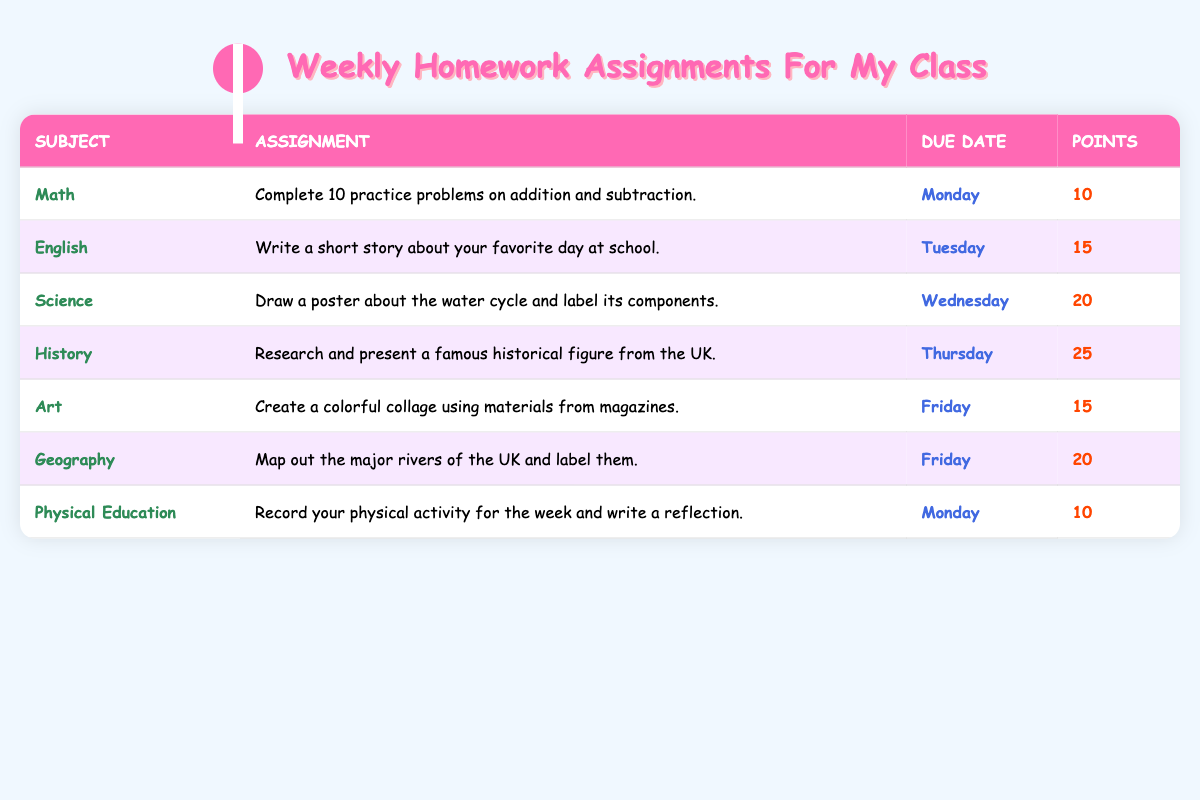What assignment is due on Wednesday? The table shows that the assignment for Science, which is "Draw a poster about the water cycle and label its components," is due on Wednesday.
Answer: Science How many points is the English assignment worth? According to the table, the English assignment, which is "Write a short story about your favorite day at school," is worth 15 points.
Answer: 15 Which subject has the highest points for its assignment? By comparing the points column, History has the highest points with 25 for the assignment "Research and present a famous historical figure from the UK."
Answer: History What assignments are due on Friday? The table lists two assignments due on Friday: "Create a colorful collage using materials from magazines" for Art and "Map out the major rivers of the UK and label them" for Geography.
Answer: Art and Geography What is the total number of points for assignments due on Monday? The assignments due on Monday are Math (10 points) and Physical Education (10 points). Adding these gives 10 + 10 = 20 points.
Answer: 20 Are there any assignments due on the weekend? The table shows that there are no assignments listed for the weekend. Therefore, there are no assignments due on Saturday or Sunday.
Answer: No What is the average points value for all assignments? The total points for all assignments (10 + 15 + 20 + 25 + 15 + 20 + 10) equals 115. With 7 assignments, the average is 115/7 = approximately 16.43.
Answer: Approximately 16.43 If I complete all the assignments, how many points will I earn? Adding all the points from the table results in a total of 115 points (10 + 15 + 20 + 25 + 15 + 20 + 10).
Answer: 115 Which subject has an assignment due on Tuesday? The English assignment, "Write a short story about your favorite day at school," is due on Tuesday.
Answer: English Is the points value for Geography greater than the average points value of all subjects? The Geography assignment is worth 20 points. The calculated average is approximately 16.43, which means 20 is greater than 16.43. Therefore, yes, it is greater.
Answer: Yes 